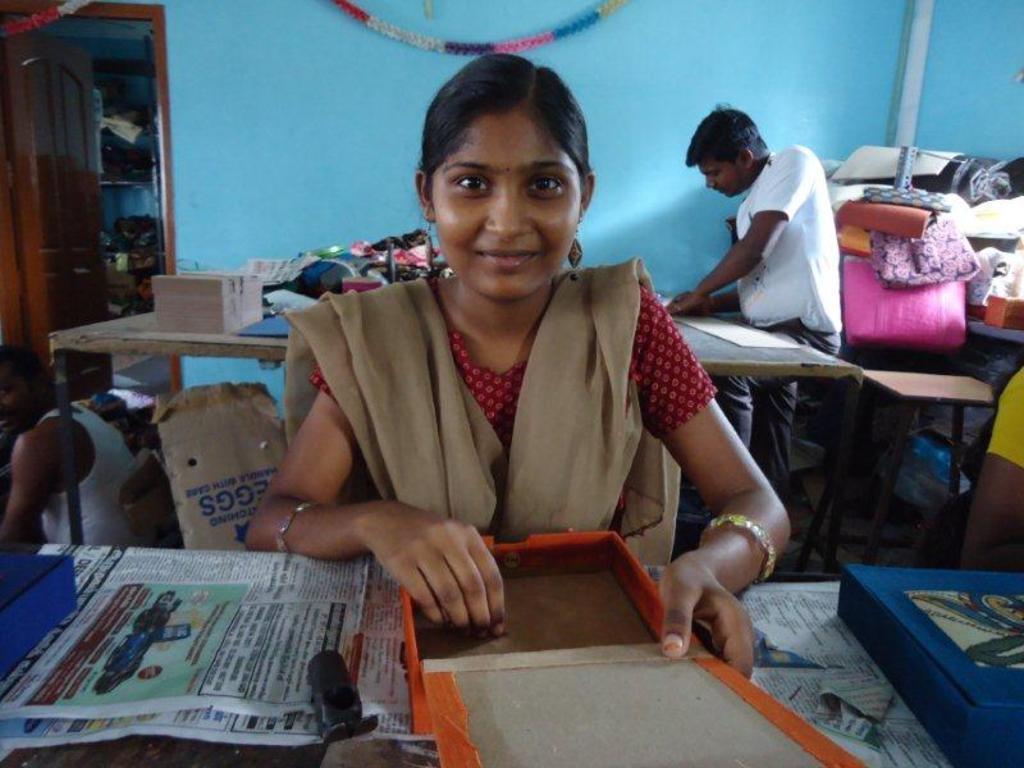How would you summarize this image in a sentence or two? Here in this picture we can see a woman sitting over a place with a table in front of her having newspaper and cardboard boxes present on it and we can see she is smiling and behind her also we can see a table, on which we can see some things present and on the right side we can see a man writing something on the paper and we can see some clothes present over there and on the left side we can see another man sitting and we can also see other things present and we can also see a door present. 